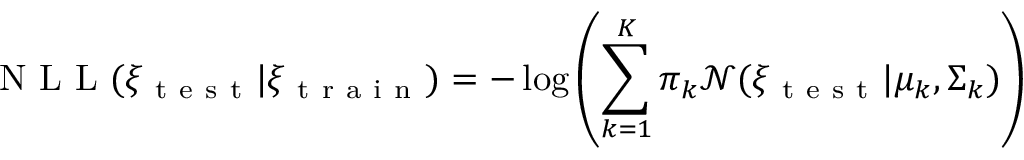Convert formula to latex. <formula><loc_0><loc_0><loc_500><loc_500>N L L ( \xi _ { t e s t } | \xi _ { t r a i n } ) = - \log \left ( \sum _ { k = 1 } ^ { K } \pi _ { k } \mathcal { N } ( \xi _ { t e s t } | \mu _ { k } , \Sigma _ { k } ) \right )</formula> 